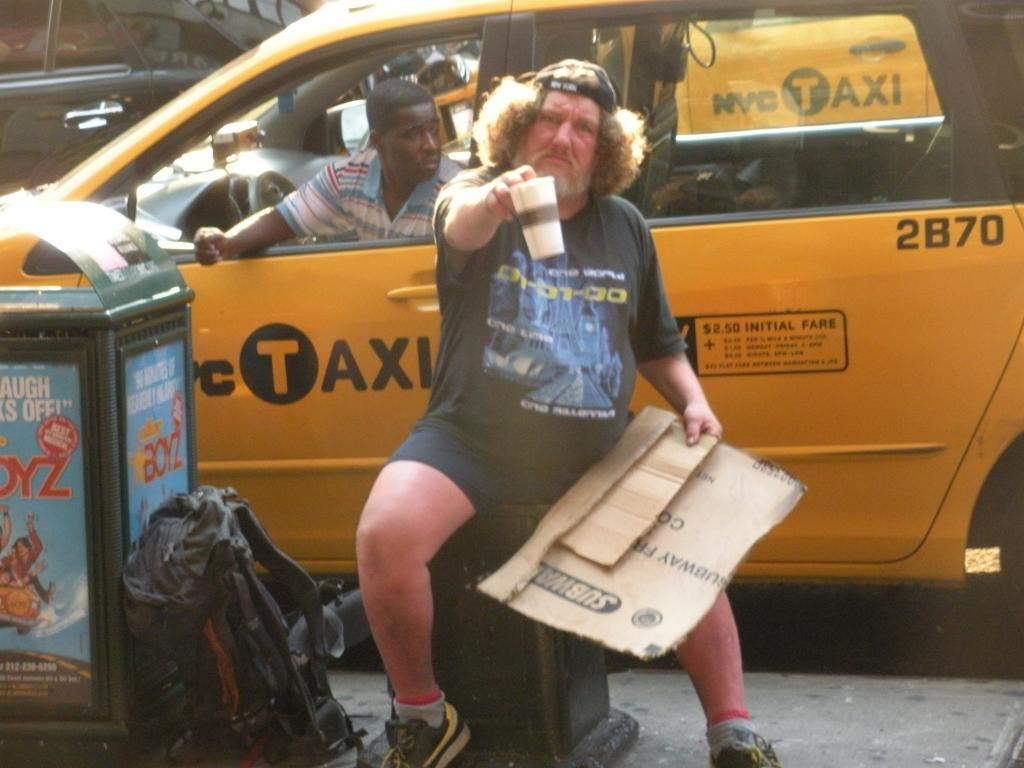Provide a one-sentence caption for the provided image. A man sitting next to a trash can with a yellow taxi cab behind him. 